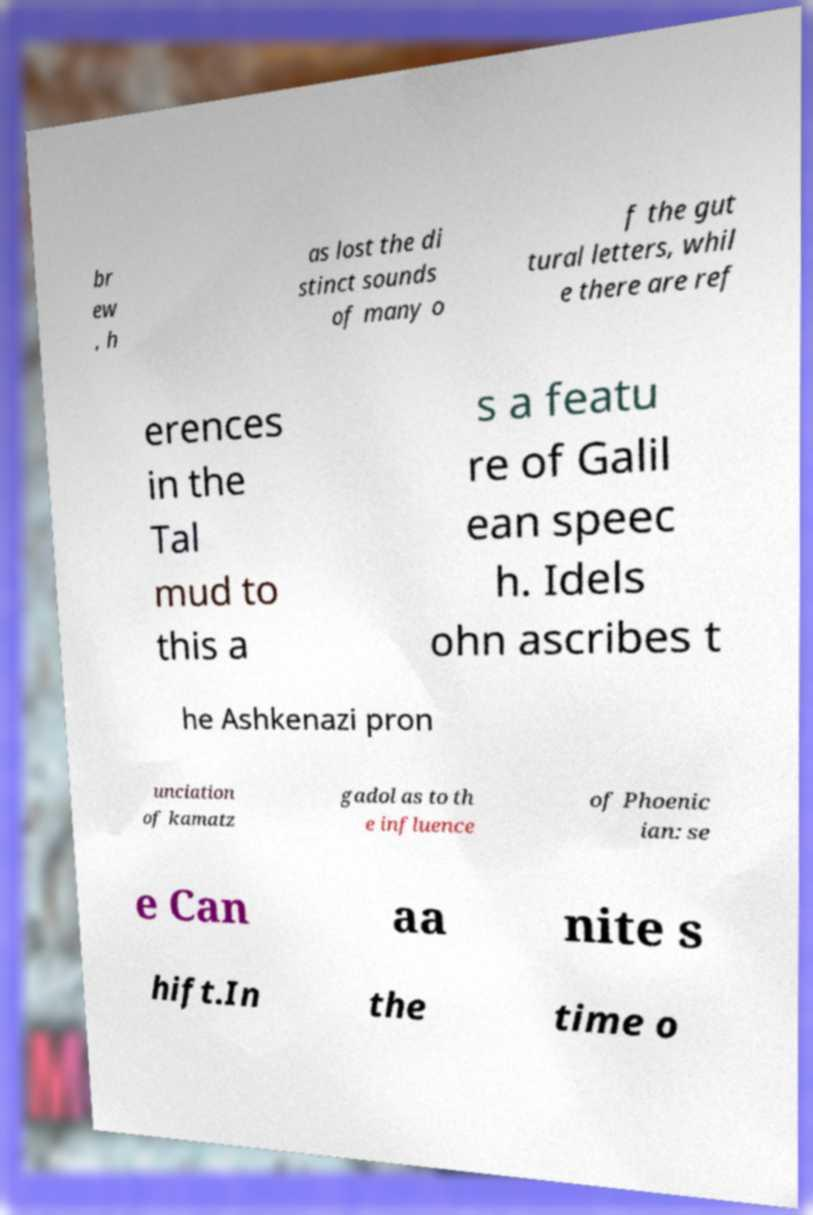I need the written content from this picture converted into text. Can you do that? br ew , h as lost the di stinct sounds of many o f the gut tural letters, whil e there are ref erences in the Tal mud to this a s a featu re of Galil ean speec h. Idels ohn ascribes t he Ashkenazi pron unciation of kamatz gadol as to th e influence of Phoenic ian: se e Can aa nite s hift.In the time o 